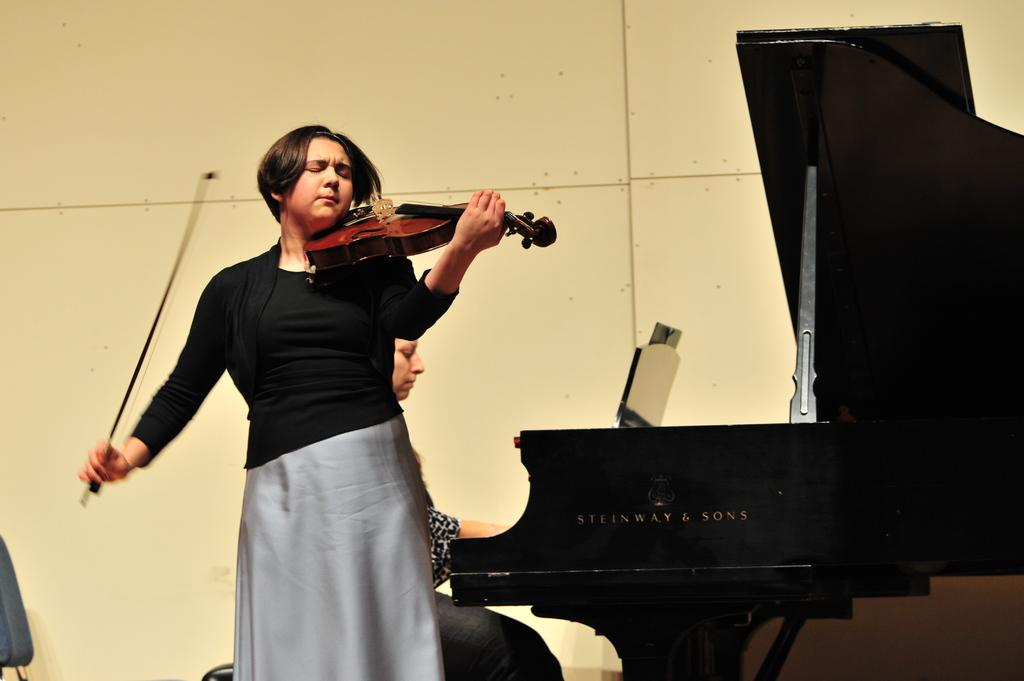What is the woman in the image doing? The woman is playing a musical instrument. What can be seen in the background of the image? There is a wall visible in the background. How many people are playing musical instruments in the image? There are two people playing musical instruments in the image. What instrument is the other person playing? The other person is playing a piano. What is the taste of the plastic in the image? There is no plastic or taste mentioned in the image; it features a woman and another person playing musical instruments. 